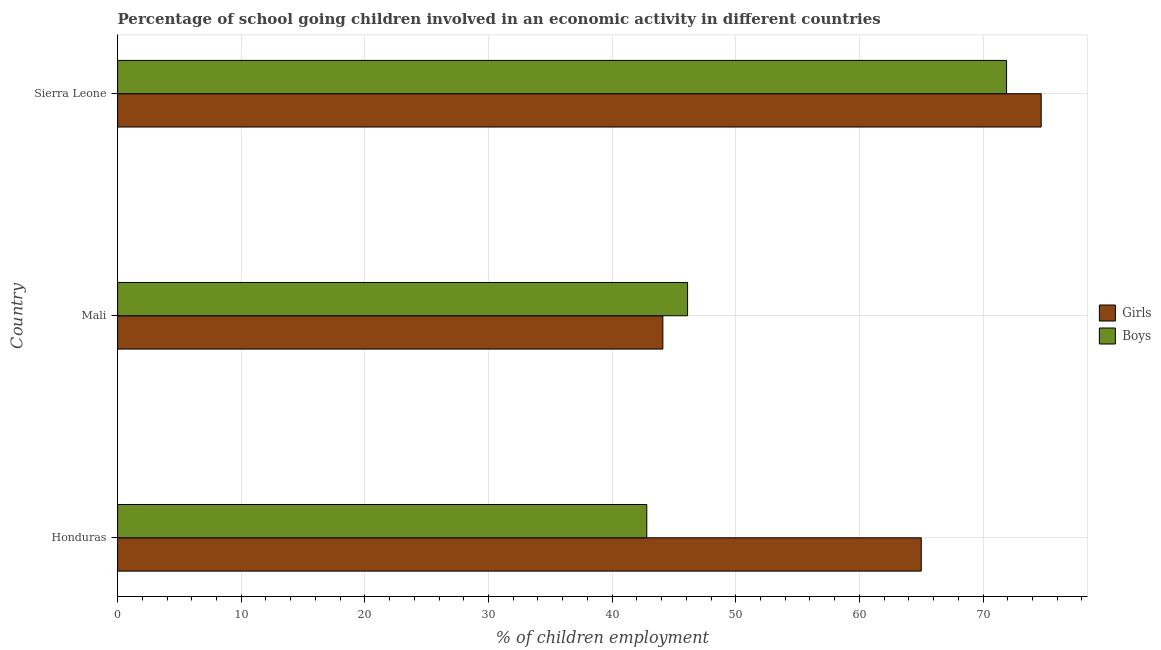How many different coloured bars are there?
Offer a very short reply. 2. How many groups of bars are there?
Your answer should be very brief. 3. How many bars are there on the 1st tick from the bottom?
Offer a very short reply. 2. What is the label of the 2nd group of bars from the top?
Keep it short and to the point. Mali. In how many cases, is the number of bars for a given country not equal to the number of legend labels?
Provide a short and direct response. 0. What is the percentage of school going boys in Sierra Leone?
Offer a very short reply. 71.9. Across all countries, what is the maximum percentage of school going girls?
Provide a short and direct response. 74.7. Across all countries, what is the minimum percentage of school going boys?
Make the answer very short. 42.8. In which country was the percentage of school going girls maximum?
Make the answer very short. Sierra Leone. In which country was the percentage of school going girls minimum?
Keep it short and to the point. Mali. What is the total percentage of school going girls in the graph?
Your response must be concise. 183.8. What is the difference between the percentage of school going boys in Mali and that in Sierra Leone?
Offer a terse response. -25.8. What is the difference between the percentage of school going boys in Mali and the percentage of school going girls in Sierra Leone?
Your answer should be very brief. -28.6. What is the average percentage of school going girls per country?
Offer a terse response. 61.27. What is the ratio of the percentage of school going girls in Honduras to that in Sierra Leone?
Provide a short and direct response. 0.87. Is the difference between the percentage of school going girls in Honduras and Mali greater than the difference between the percentage of school going boys in Honduras and Mali?
Keep it short and to the point. Yes. What is the difference between the highest and the lowest percentage of school going boys?
Offer a very short reply. 29.1. What does the 2nd bar from the top in Honduras represents?
Make the answer very short. Girls. What does the 1st bar from the bottom in Honduras represents?
Make the answer very short. Girls. How many bars are there?
Provide a succinct answer. 6. What is the difference between two consecutive major ticks on the X-axis?
Your response must be concise. 10. Are the values on the major ticks of X-axis written in scientific E-notation?
Provide a short and direct response. No. Does the graph contain any zero values?
Make the answer very short. No. Where does the legend appear in the graph?
Keep it short and to the point. Center right. How many legend labels are there?
Provide a short and direct response. 2. What is the title of the graph?
Make the answer very short. Percentage of school going children involved in an economic activity in different countries. Does "IMF nonconcessional" appear as one of the legend labels in the graph?
Offer a very short reply. No. What is the label or title of the X-axis?
Offer a very short reply. % of children employment. What is the % of children employment of Girls in Honduras?
Your answer should be compact. 65. What is the % of children employment in Boys in Honduras?
Your answer should be compact. 42.8. What is the % of children employment of Girls in Mali?
Your answer should be compact. 44.1. What is the % of children employment in Boys in Mali?
Ensure brevity in your answer.  46.1. What is the % of children employment in Girls in Sierra Leone?
Make the answer very short. 74.7. What is the % of children employment of Boys in Sierra Leone?
Your answer should be very brief. 71.9. Across all countries, what is the maximum % of children employment of Girls?
Ensure brevity in your answer.  74.7. Across all countries, what is the maximum % of children employment in Boys?
Offer a very short reply. 71.9. Across all countries, what is the minimum % of children employment of Girls?
Provide a short and direct response. 44.1. Across all countries, what is the minimum % of children employment in Boys?
Provide a succinct answer. 42.8. What is the total % of children employment in Girls in the graph?
Make the answer very short. 183.8. What is the total % of children employment in Boys in the graph?
Your answer should be very brief. 160.8. What is the difference between the % of children employment in Girls in Honduras and that in Mali?
Provide a succinct answer. 20.9. What is the difference between the % of children employment of Boys in Honduras and that in Mali?
Your answer should be very brief. -3.3. What is the difference between the % of children employment of Girls in Honduras and that in Sierra Leone?
Your response must be concise. -9.7. What is the difference between the % of children employment in Boys in Honduras and that in Sierra Leone?
Your answer should be very brief. -29.1. What is the difference between the % of children employment in Girls in Mali and that in Sierra Leone?
Your answer should be compact. -30.6. What is the difference between the % of children employment in Boys in Mali and that in Sierra Leone?
Make the answer very short. -25.8. What is the difference between the % of children employment of Girls in Honduras and the % of children employment of Boys in Sierra Leone?
Offer a very short reply. -6.9. What is the difference between the % of children employment in Girls in Mali and the % of children employment in Boys in Sierra Leone?
Provide a short and direct response. -27.8. What is the average % of children employment of Girls per country?
Provide a succinct answer. 61.27. What is the average % of children employment in Boys per country?
Provide a succinct answer. 53.6. What is the difference between the % of children employment in Girls and % of children employment in Boys in Honduras?
Provide a short and direct response. 22.2. What is the difference between the % of children employment of Girls and % of children employment of Boys in Mali?
Provide a short and direct response. -2. What is the difference between the % of children employment of Girls and % of children employment of Boys in Sierra Leone?
Keep it short and to the point. 2.8. What is the ratio of the % of children employment of Girls in Honduras to that in Mali?
Provide a short and direct response. 1.47. What is the ratio of the % of children employment of Boys in Honduras to that in Mali?
Make the answer very short. 0.93. What is the ratio of the % of children employment in Girls in Honduras to that in Sierra Leone?
Your answer should be very brief. 0.87. What is the ratio of the % of children employment of Boys in Honduras to that in Sierra Leone?
Your answer should be compact. 0.6. What is the ratio of the % of children employment of Girls in Mali to that in Sierra Leone?
Offer a very short reply. 0.59. What is the ratio of the % of children employment in Boys in Mali to that in Sierra Leone?
Offer a very short reply. 0.64. What is the difference between the highest and the second highest % of children employment in Girls?
Make the answer very short. 9.7. What is the difference between the highest and the second highest % of children employment in Boys?
Make the answer very short. 25.8. What is the difference between the highest and the lowest % of children employment of Girls?
Give a very brief answer. 30.6. What is the difference between the highest and the lowest % of children employment in Boys?
Keep it short and to the point. 29.1. 